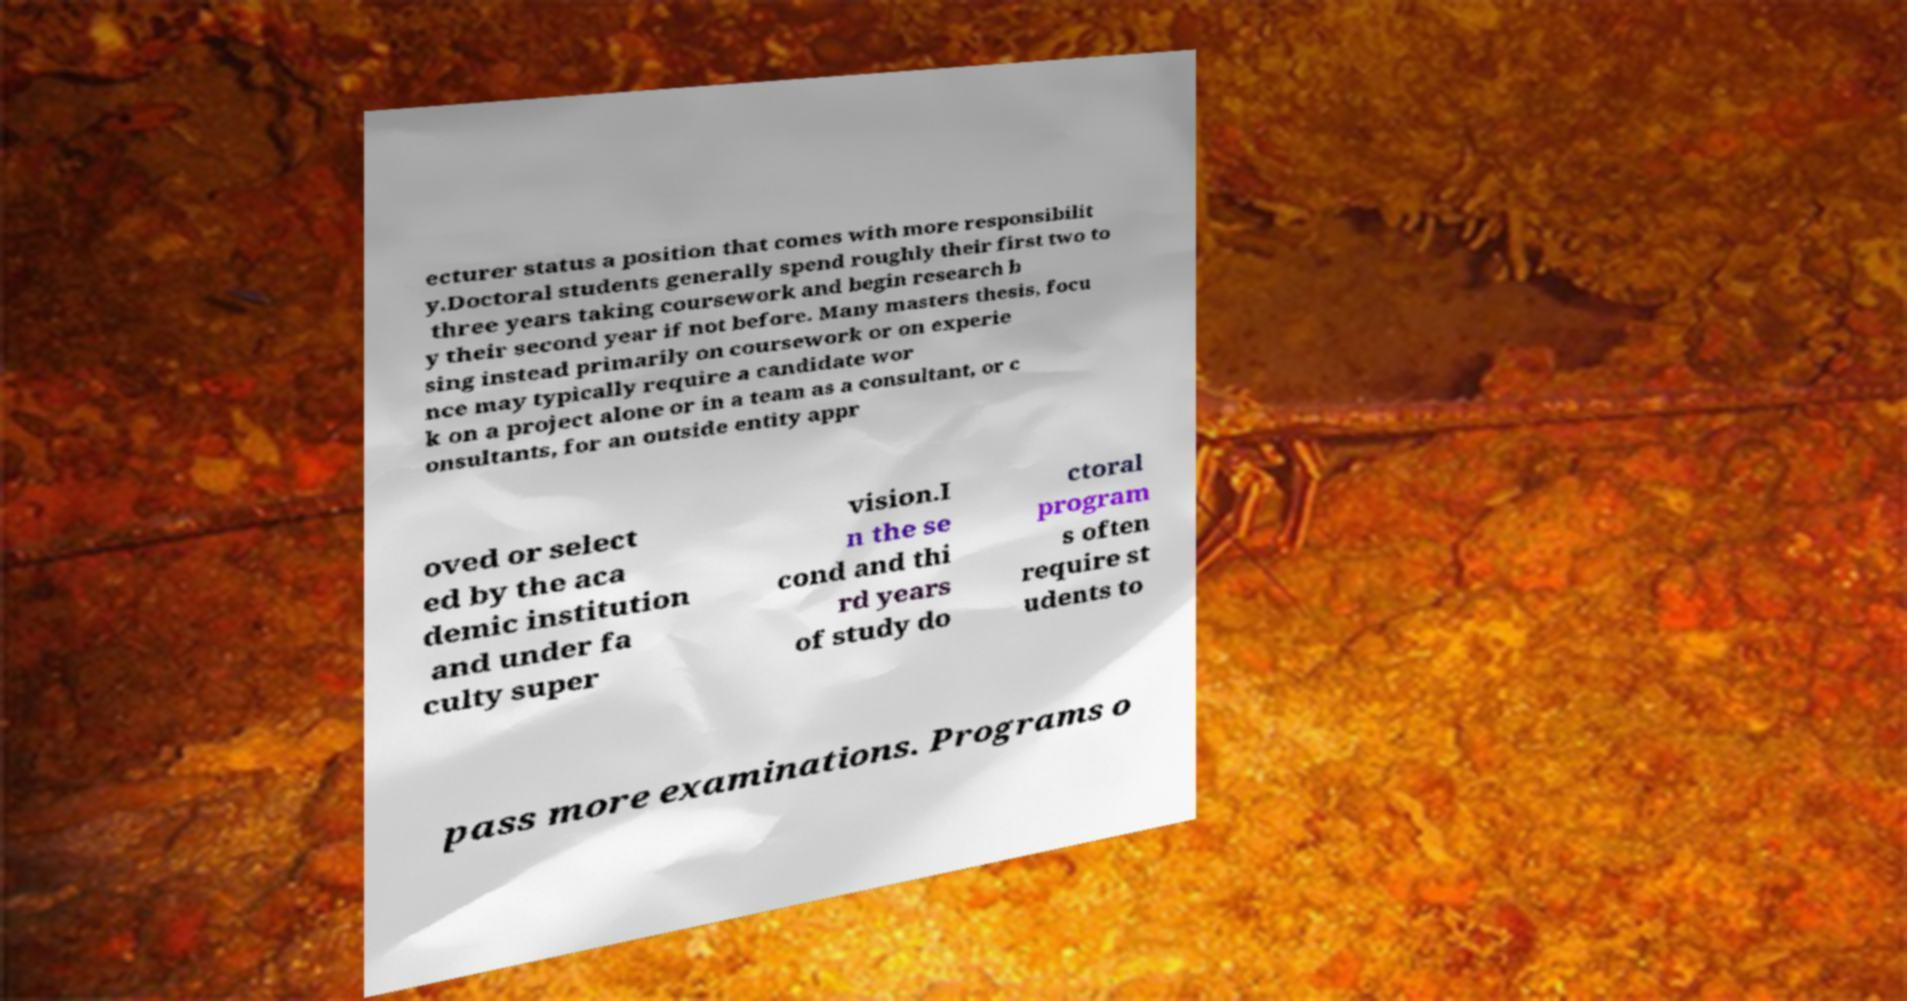Could you assist in decoding the text presented in this image and type it out clearly? ecturer status a position that comes with more responsibilit y.Doctoral students generally spend roughly their first two to three years taking coursework and begin research b y their second year if not before. Many masters thesis, focu sing instead primarily on coursework or on experie nce may typically require a candidate wor k on a project alone or in a team as a consultant, or c onsultants, for an outside entity appr oved or select ed by the aca demic institution and under fa culty super vision.I n the se cond and thi rd years of study do ctoral program s often require st udents to pass more examinations. Programs o 